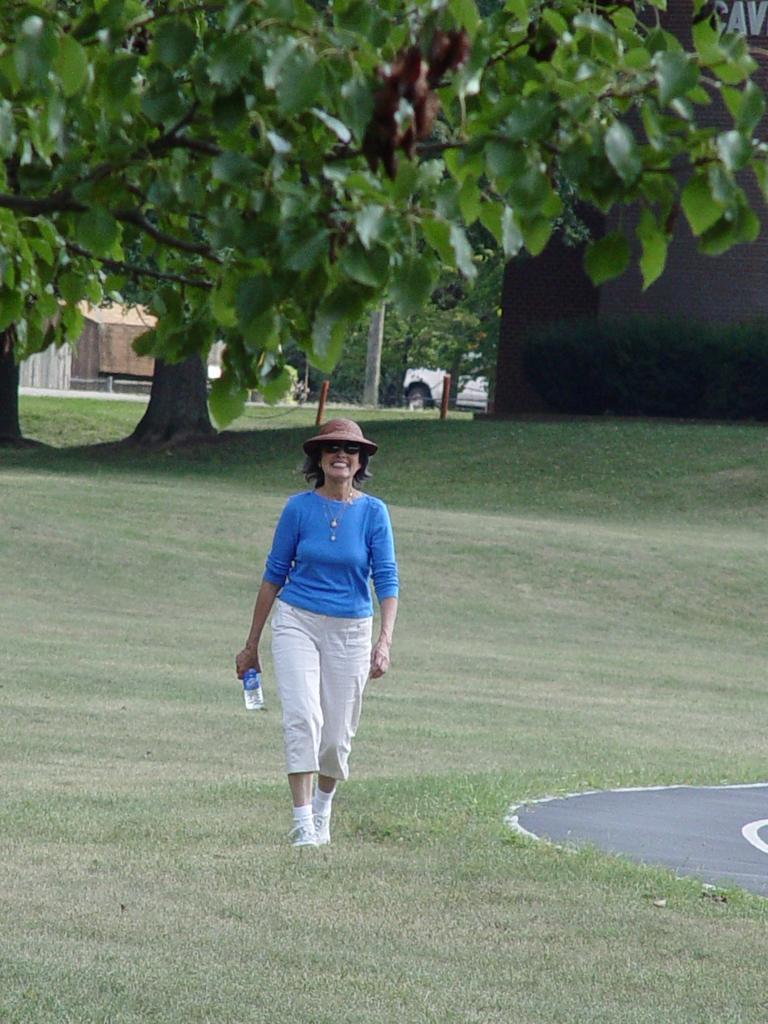Could you give a brief overview of what you see in this image? Here we can see a woman standing on the ground and she is smiling. She has spectacles and she is holding a bottle with her hand. In the background we can see trees and a vehicle. 